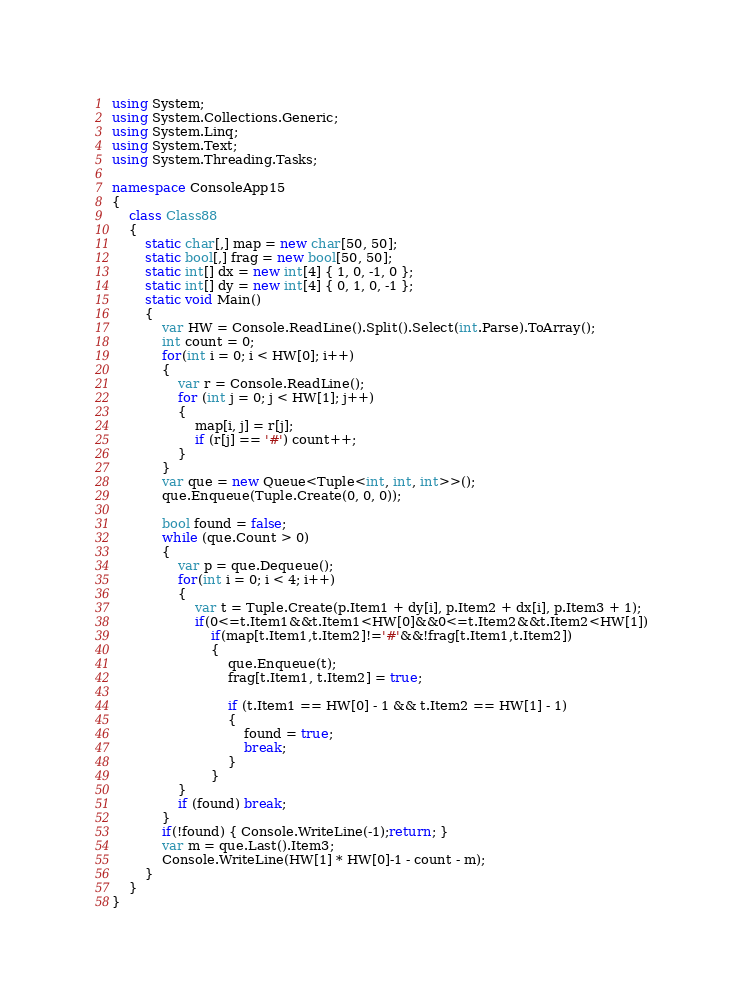<code> <loc_0><loc_0><loc_500><loc_500><_C#_>using System;
using System.Collections.Generic;
using System.Linq;
using System.Text;
using System.Threading.Tasks;

namespace ConsoleApp15
{
    class Class88
    {
        static char[,] map = new char[50, 50];
        static bool[,] frag = new bool[50, 50];
        static int[] dx = new int[4] { 1, 0, -1, 0 };
        static int[] dy = new int[4] { 0, 1, 0, -1 };
        static void Main()
        {
            var HW = Console.ReadLine().Split().Select(int.Parse).ToArray();
            int count = 0;
            for(int i = 0; i < HW[0]; i++)
            {
                var r = Console.ReadLine();
                for (int j = 0; j < HW[1]; j++)
                {
                    map[i, j] = r[j];
                    if (r[j] == '#') count++;
                }
            }
            var que = new Queue<Tuple<int, int, int>>();
            que.Enqueue(Tuple.Create(0, 0, 0));

            bool found = false;
            while (que.Count > 0)
            {
                var p = que.Dequeue();
                for(int i = 0; i < 4; i++)
                {
                    var t = Tuple.Create(p.Item1 + dy[i], p.Item2 + dx[i], p.Item3 + 1);
                    if(0<=t.Item1&&t.Item1<HW[0]&&0<=t.Item2&&t.Item2<HW[1])
                        if(map[t.Item1,t.Item2]!='#'&&!frag[t.Item1,t.Item2])
                        {
                            que.Enqueue(t);
                            frag[t.Item1, t.Item2] = true;

                            if (t.Item1 == HW[0] - 1 && t.Item2 == HW[1] - 1)
                            {
                                found = true;
                                break;
                            }
                        }
                }
                if (found) break;
            }
            if(!found) { Console.WriteLine(-1);return; }
            var m = que.Last().Item3;
            Console.WriteLine(HW[1] * HW[0]-1 - count - m);
        }
    }
}
</code> 